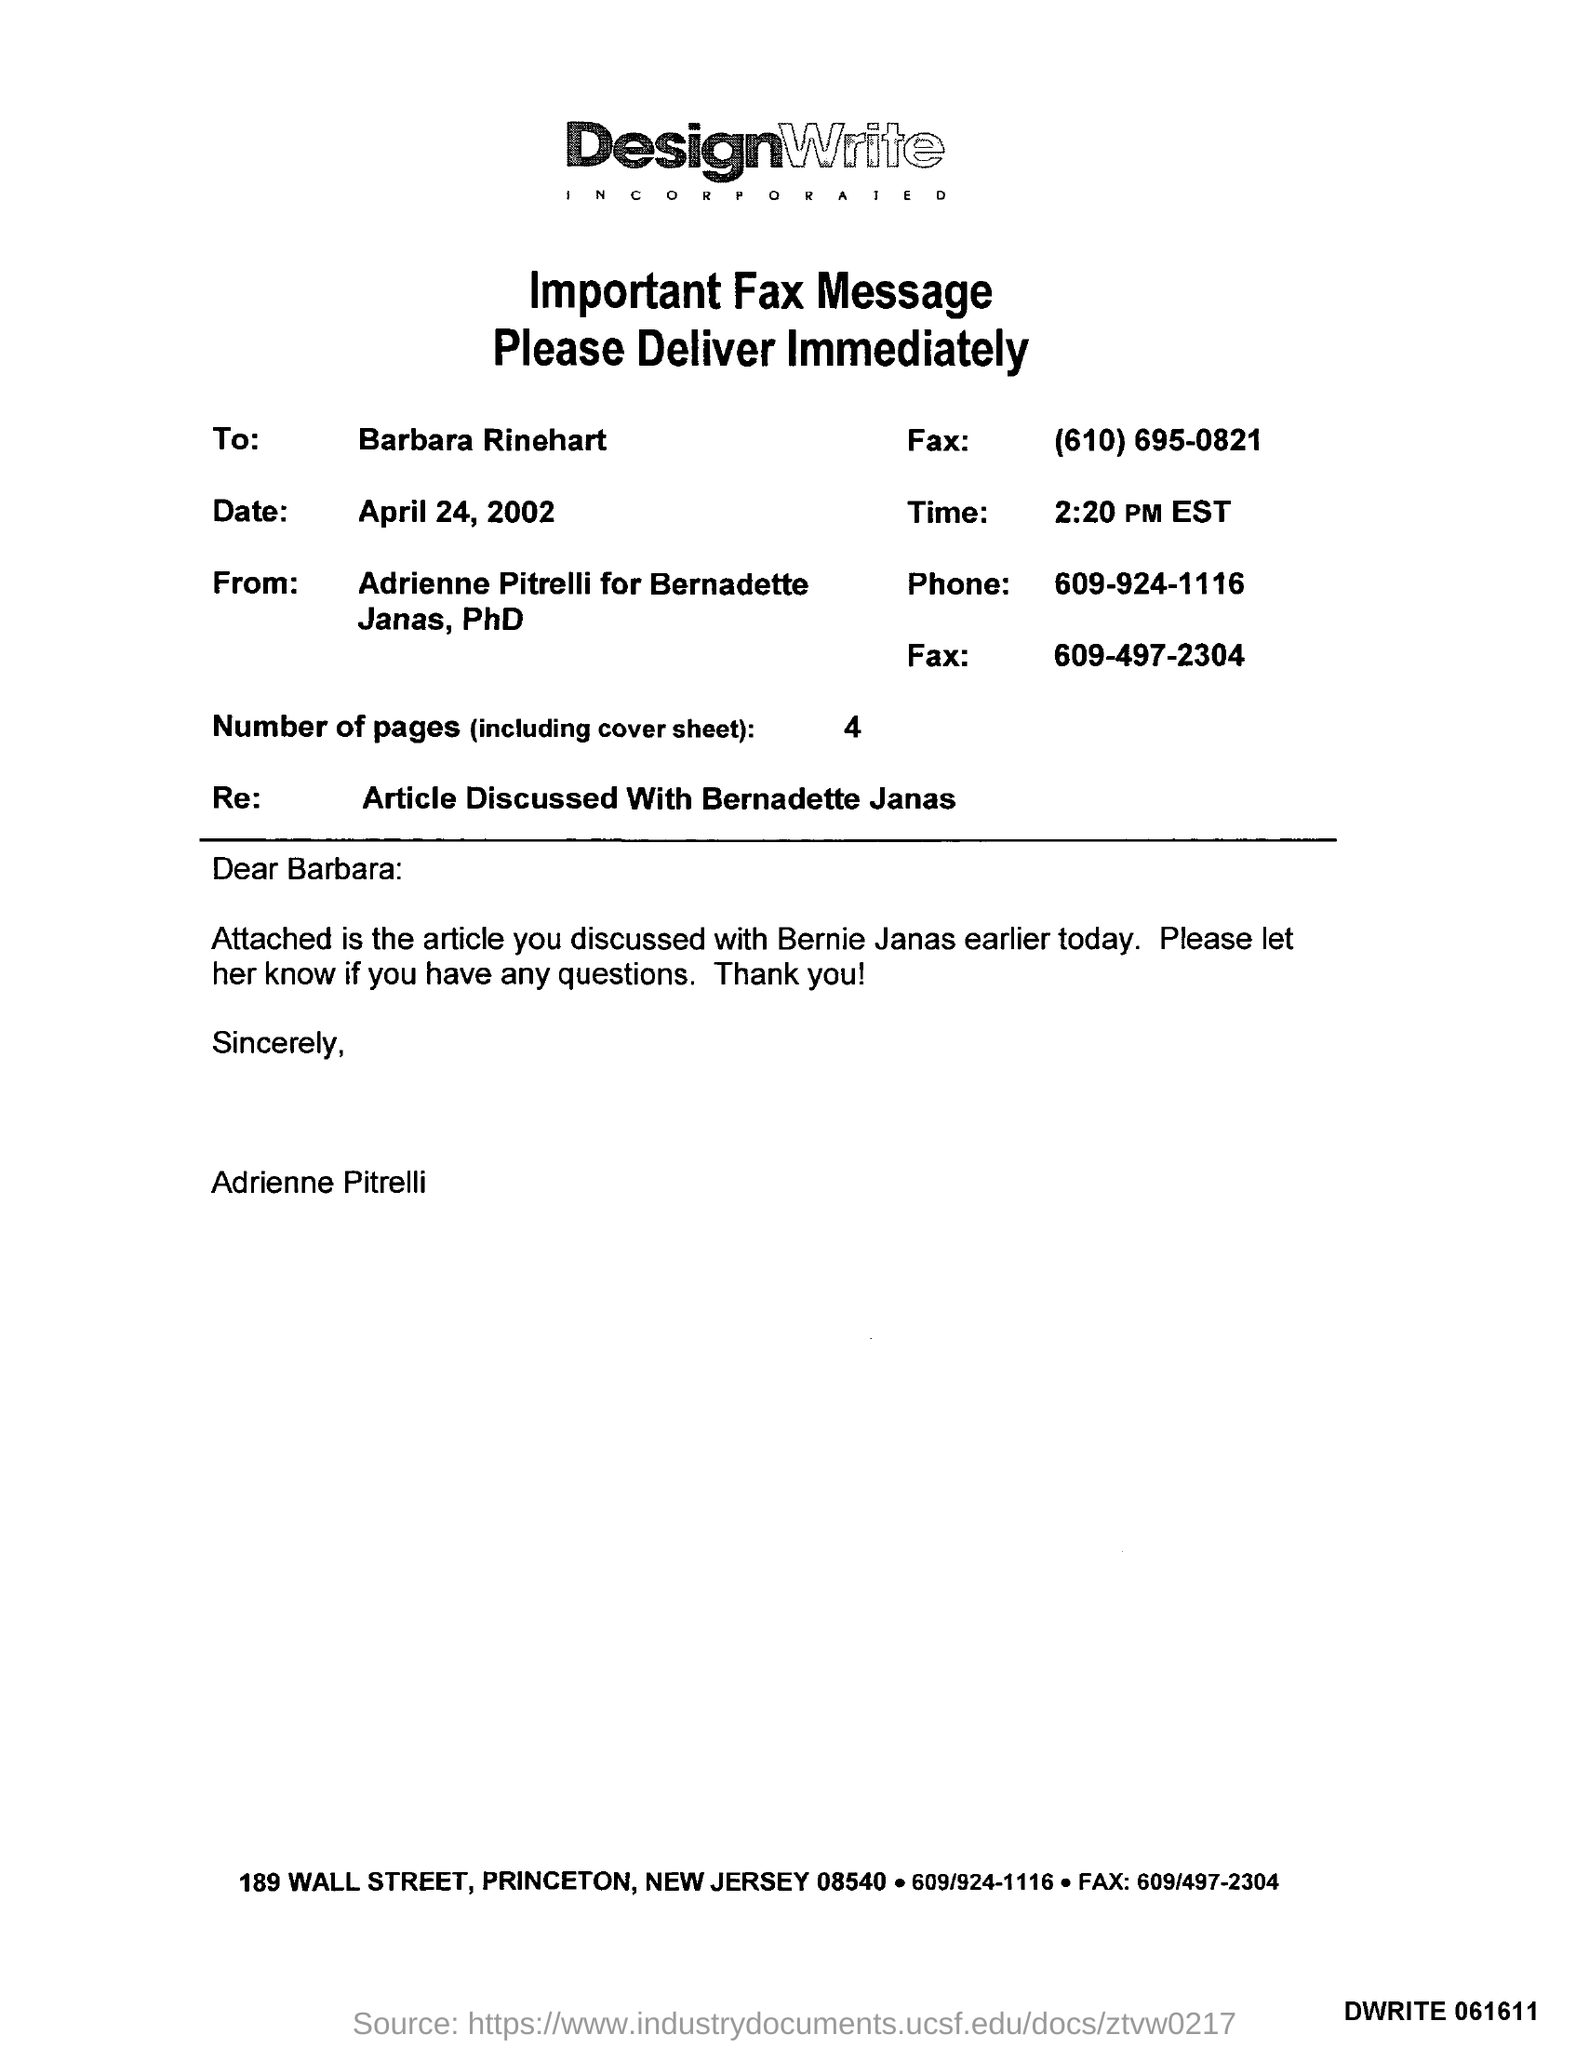Highlight a few significant elements in this photo. The date mentioned in the fax is April 24, 2002. This fax message belongs to DesignWrite Incorporated. There are four pages in the fax, including the cover sheet. The fax is being sent to Barbara Rinehart. The time mentioned in the fax is 2:20 PM EST. 